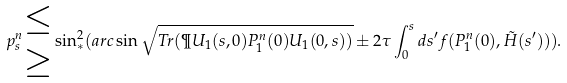Convert formula to latex. <formula><loc_0><loc_0><loc_500><loc_500>p _ { s } ^ { n } \begin{matrix} \leq \\ \geq \end{matrix} \sin _ { * } ^ { 2 } ( a r c \sin \sqrt { T r ( \P U _ { 1 } ( s , 0 ) P _ { 1 } ^ { n } ( 0 ) U _ { 1 } ( 0 , s ) ) } \pm 2 \tau \int _ { 0 } ^ { s } d s ^ { \prime } f ( P _ { 1 } ^ { n } ( 0 ) , \tilde { H } ( s ^ { \prime } ) ) ) .</formula> 